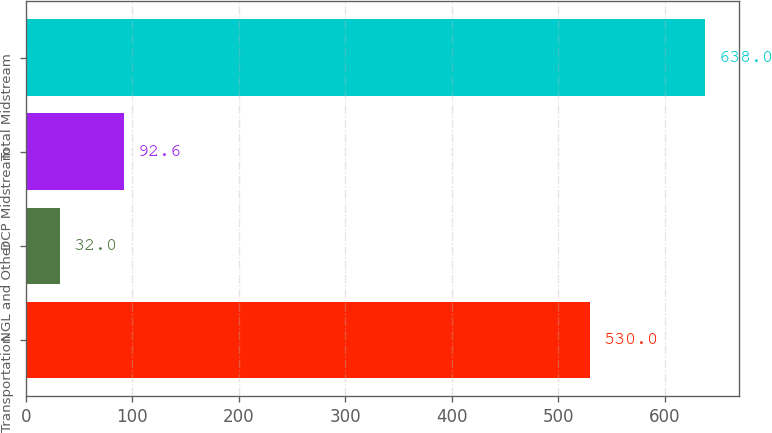<chart> <loc_0><loc_0><loc_500><loc_500><bar_chart><fcel>Transportation<fcel>NGL and Other<fcel>DCP Midstream<fcel>Total Midstream<nl><fcel>530<fcel>32<fcel>92.6<fcel>638<nl></chart> 